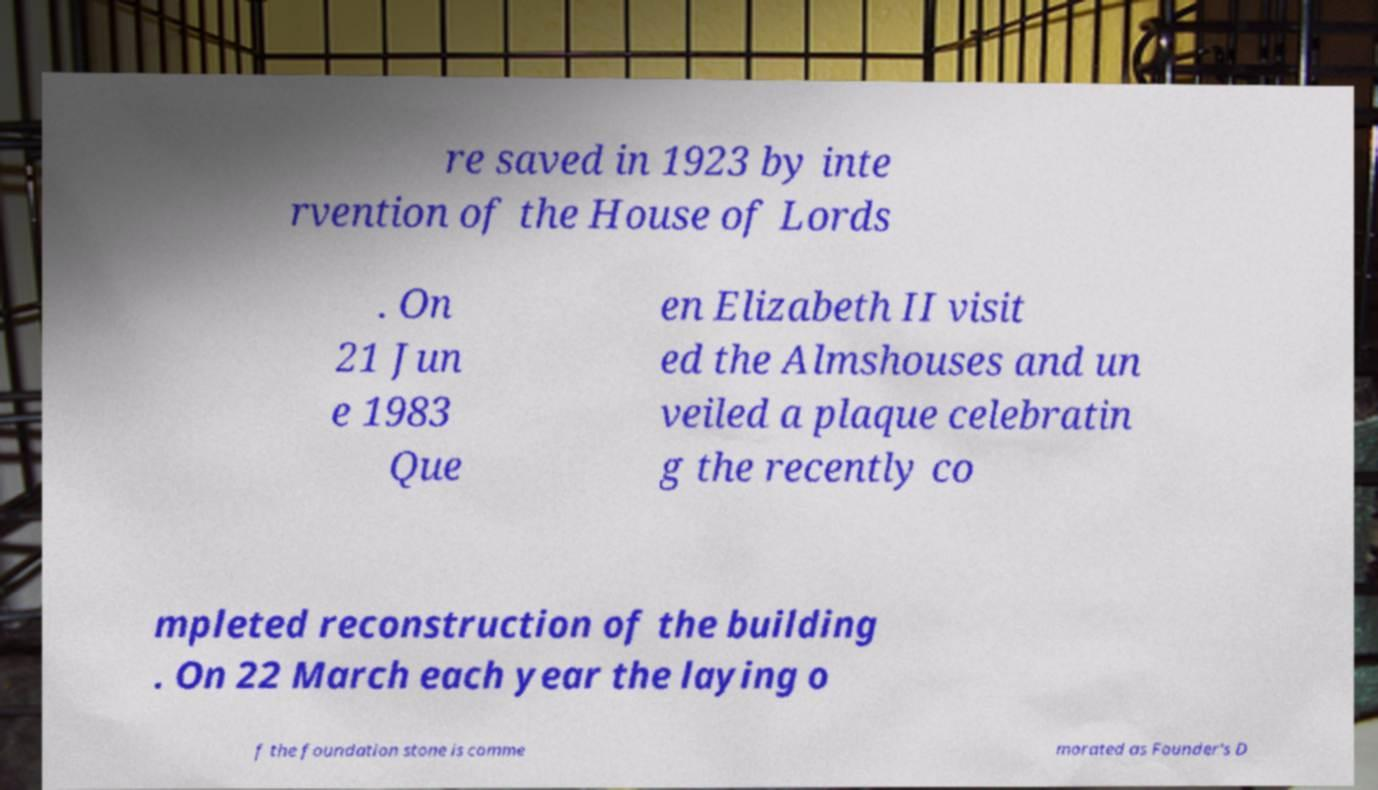Could you assist in decoding the text presented in this image and type it out clearly? re saved in 1923 by inte rvention of the House of Lords . On 21 Jun e 1983 Que en Elizabeth II visit ed the Almshouses and un veiled a plaque celebratin g the recently co mpleted reconstruction of the building . On 22 March each year the laying o f the foundation stone is comme morated as Founder's D 